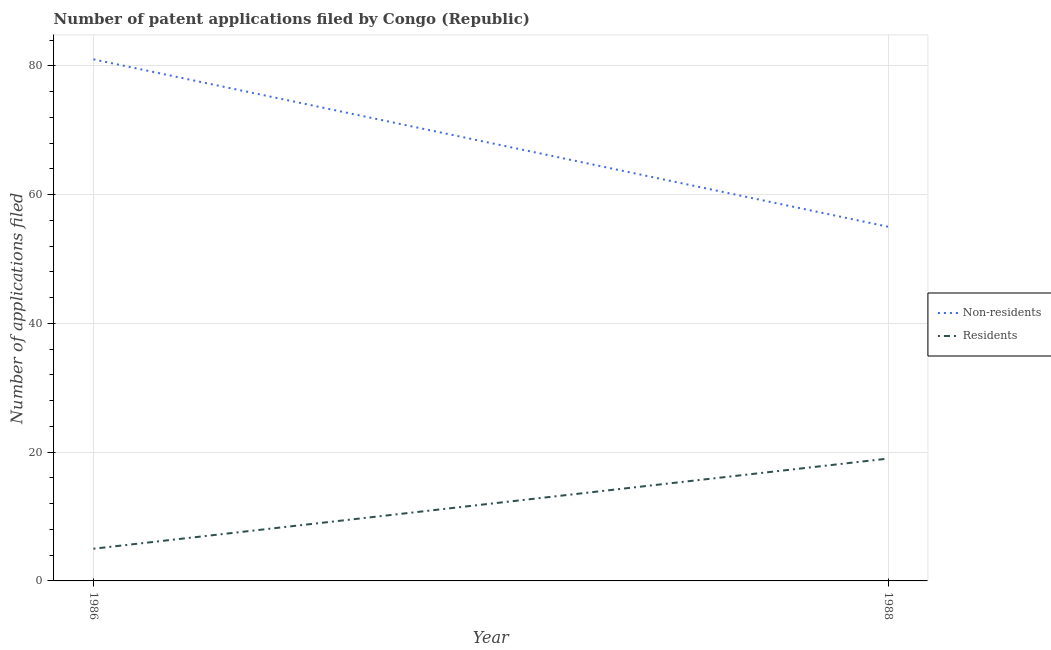What is the number of patent applications by residents in 1986?
Make the answer very short. 5. Across all years, what is the maximum number of patent applications by non residents?
Your answer should be compact. 81. Across all years, what is the minimum number of patent applications by non residents?
Give a very brief answer. 55. What is the total number of patent applications by non residents in the graph?
Make the answer very short. 136. What is the difference between the number of patent applications by residents in 1986 and that in 1988?
Ensure brevity in your answer.  -14. What is the difference between the number of patent applications by residents in 1986 and the number of patent applications by non residents in 1988?
Provide a succinct answer. -50. What is the average number of patent applications by non residents per year?
Your answer should be compact. 68. In the year 1986, what is the difference between the number of patent applications by non residents and number of patent applications by residents?
Your response must be concise. 76. In how many years, is the number of patent applications by residents greater than 16?
Your response must be concise. 1. What is the ratio of the number of patent applications by residents in 1986 to that in 1988?
Offer a very short reply. 0.26. In how many years, is the number of patent applications by non residents greater than the average number of patent applications by non residents taken over all years?
Your response must be concise. 1. Is the number of patent applications by non residents strictly greater than the number of patent applications by residents over the years?
Make the answer very short. Yes. Is the number of patent applications by residents strictly less than the number of patent applications by non residents over the years?
Your response must be concise. Yes. How many lines are there?
Provide a short and direct response. 2. Does the graph contain grids?
Provide a succinct answer. Yes. How are the legend labels stacked?
Give a very brief answer. Vertical. What is the title of the graph?
Offer a very short reply. Number of patent applications filed by Congo (Republic). Does "Investments" appear as one of the legend labels in the graph?
Offer a very short reply. No. What is the label or title of the Y-axis?
Provide a short and direct response. Number of applications filed. What is the Number of applications filed in Residents in 1986?
Keep it short and to the point. 5. What is the Number of applications filed of Residents in 1988?
Your answer should be very brief. 19. What is the total Number of applications filed in Non-residents in the graph?
Provide a short and direct response. 136. What is the difference between the Number of applications filed of Non-residents in 1986 and that in 1988?
Your response must be concise. 26. What is the difference between the Number of applications filed of Residents in 1986 and that in 1988?
Make the answer very short. -14. What is the average Number of applications filed in Non-residents per year?
Your response must be concise. 68. In the year 1986, what is the difference between the Number of applications filed in Non-residents and Number of applications filed in Residents?
Offer a very short reply. 76. What is the ratio of the Number of applications filed in Non-residents in 1986 to that in 1988?
Provide a short and direct response. 1.47. What is the ratio of the Number of applications filed of Residents in 1986 to that in 1988?
Provide a short and direct response. 0.26. What is the difference between the highest and the lowest Number of applications filed in Residents?
Provide a short and direct response. 14. 